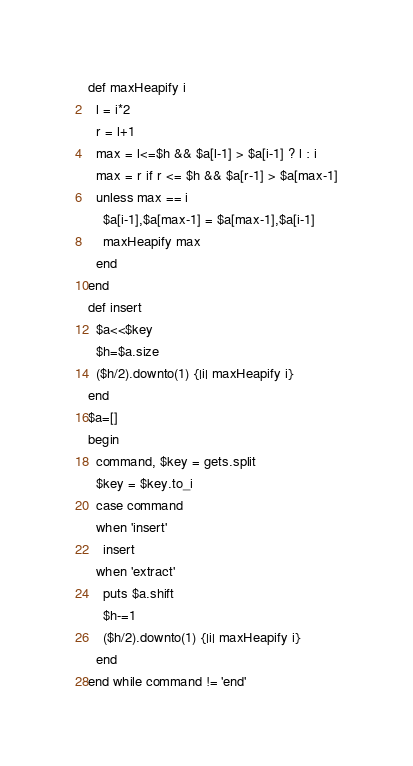Convert code to text. <code><loc_0><loc_0><loc_500><loc_500><_Ruby_>def maxHeapify i
  l = i*2
  r = l+1
  max = l<=$h && $a[l-1] > $a[i-1] ? l : i
  max = r if r <= $h && $a[r-1] > $a[max-1]
  unless max == i
    $a[i-1],$a[max-1] = $a[max-1],$a[i-1]
    maxHeapify max
  end
end
def insert
  $a<<$key
  $h=$a.size
  ($h/2).downto(1) {|i| maxHeapify i}
end
$a=[]
begin
  command, $key = gets.split
  $key = $key.to_i
  case command
  when 'insert'
    insert
  when 'extract'
    puts $a.shift
    $h-=1
    ($h/2).downto(1) {|i| maxHeapify i}
  end
end while command != 'end'</code> 